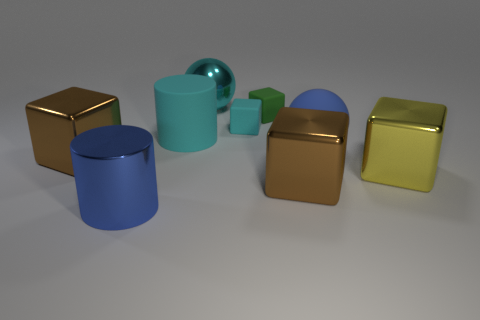The cylinder behind the brown metal thing that is in front of the brown thing on the left side of the small cyan object is made of what material?
Your response must be concise. Rubber. There is a cyan thing that is in front of the cyan block; what is its material?
Give a very brief answer. Rubber. Are there any rubber balls that have the same size as the blue cylinder?
Ensure brevity in your answer.  Yes. Do the large shiny ball that is on the right side of the big cyan rubber object and the large shiny cylinder have the same color?
Ensure brevity in your answer.  No. How many blue things are either large balls or big blocks?
Offer a very short reply. 1. What number of cylinders have the same color as the shiny ball?
Make the answer very short. 1. Is the blue ball made of the same material as the big yellow block?
Keep it short and to the point. No. There is a big brown metallic thing that is to the right of the green thing; how many large metallic cylinders are left of it?
Ensure brevity in your answer.  1. Do the blue matte object and the yellow cube have the same size?
Give a very brief answer. Yes. What number of things are made of the same material as the yellow cube?
Make the answer very short. 4. 